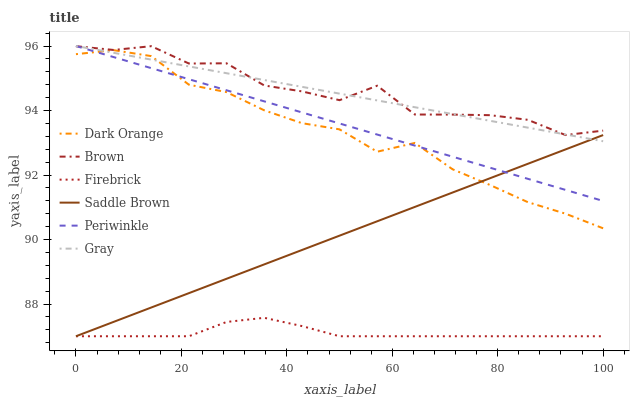Does Firebrick have the minimum area under the curve?
Answer yes or no. Yes. Does Brown have the maximum area under the curve?
Answer yes or no. Yes. Does Gray have the minimum area under the curve?
Answer yes or no. No. Does Gray have the maximum area under the curve?
Answer yes or no. No. Is Gray the smoothest?
Answer yes or no. Yes. Is Brown the roughest?
Answer yes or no. Yes. Is Brown the smoothest?
Answer yes or no. No. Is Gray the roughest?
Answer yes or no. No. Does Firebrick have the lowest value?
Answer yes or no. Yes. Does Gray have the lowest value?
Answer yes or no. No. Does Periwinkle have the highest value?
Answer yes or no. Yes. Does Brown have the highest value?
Answer yes or no. No. Is Saddle Brown less than Brown?
Answer yes or no. Yes. Is Gray greater than Firebrick?
Answer yes or no. Yes. Does Dark Orange intersect Periwinkle?
Answer yes or no. Yes. Is Dark Orange less than Periwinkle?
Answer yes or no. No. Is Dark Orange greater than Periwinkle?
Answer yes or no. No. Does Saddle Brown intersect Brown?
Answer yes or no. No. 